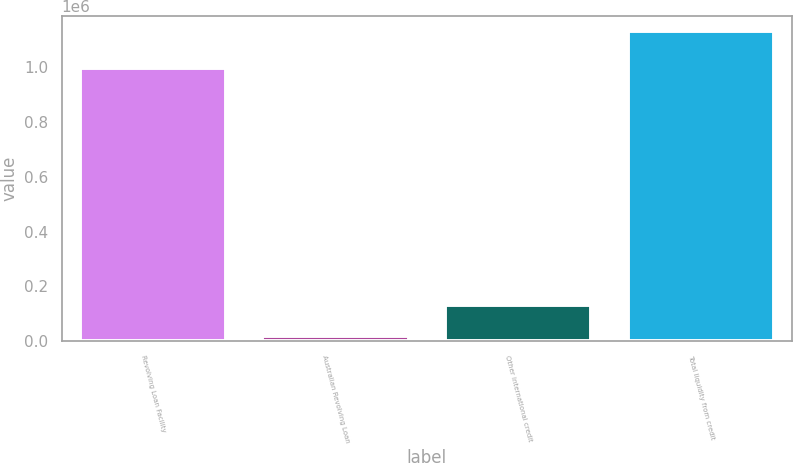<chart> <loc_0><loc_0><loc_500><loc_500><bar_chart><fcel>Revolving Loan Facility<fcel>Australian Revolving Loan<fcel>Other international credit<fcel>Total liquidity from credit<nl><fcel>995665<fcel>21118<fcel>131964<fcel>1.12958e+06<nl></chart> 